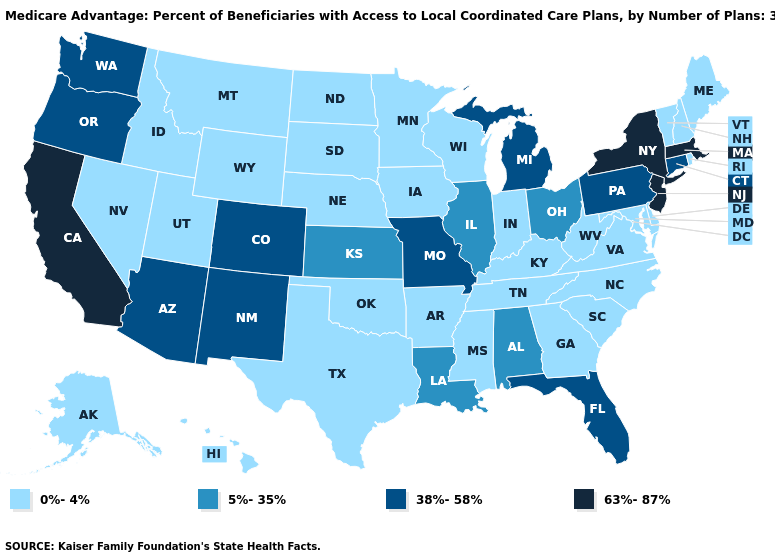Name the states that have a value in the range 63%-87%?
Be succinct. California, Massachusetts, New Jersey, New York. Name the states that have a value in the range 0%-4%?
Give a very brief answer. Alaska, Arkansas, Delaware, Georgia, Hawaii, Iowa, Idaho, Indiana, Kentucky, Maryland, Maine, Minnesota, Mississippi, Montana, North Carolina, North Dakota, Nebraska, New Hampshire, Nevada, Oklahoma, Rhode Island, South Carolina, South Dakota, Tennessee, Texas, Utah, Virginia, Vermont, Wisconsin, West Virginia, Wyoming. What is the highest value in the West ?
Concise answer only. 63%-87%. What is the value of Alabama?
Be succinct. 5%-35%. Among the states that border Georgia , which have the lowest value?
Concise answer only. North Carolina, South Carolina, Tennessee. Does the map have missing data?
Quick response, please. No. Does California have the highest value in the USA?
Write a very short answer. Yes. What is the lowest value in states that border Massachusetts?
Write a very short answer. 0%-4%. Name the states that have a value in the range 63%-87%?
Short answer required. California, Massachusetts, New Jersey, New York. What is the value of Nebraska?
Short answer required. 0%-4%. Name the states that have a value in the range 0%-4%?
Answer briefly. Alaska, Arkansas, Delaware, Georgia, Hawaii, Iowa, Idaho, Indiana, Kentucky, Maryland, Maine, Minnesota, Mississippi, Montana, North Carolina, North Dakota, Nebraska, New Hampshire, Nevada, Oklahoma, Rhode Island, South Carolina, South Dakota, Tennessee, Texas, Utah, Virginia, Vermont, Wisconsin, West Virginia, Wyoming. Name the states that have a value in the range 5%-35%?
Keep it brief. Alabama, Illinois, Kansas, Louisiana, Ohio. Does California have a lower value than Rhode Island?
Be succinct. No. Among the states that border Nevada , does Arizona have the highest value?
Keep it brief. No. What is the highest value in the MidWest ?
Give a very brief answer. 38%-58%. 